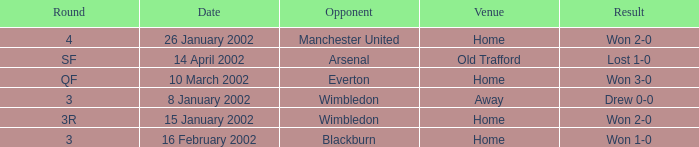What is the location on a date of 14 april 2002? Old Trafford. 